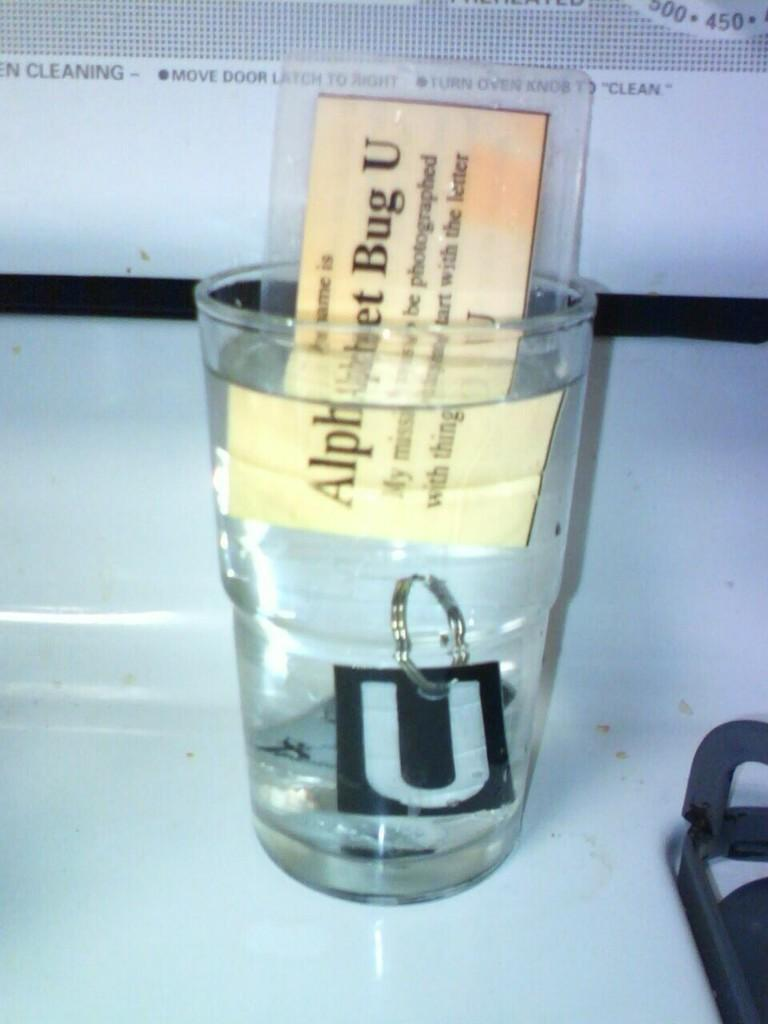<image>
Relay a brief, clear account of the picture shown. A glass of water containing a card reading Alphabet Bug U 